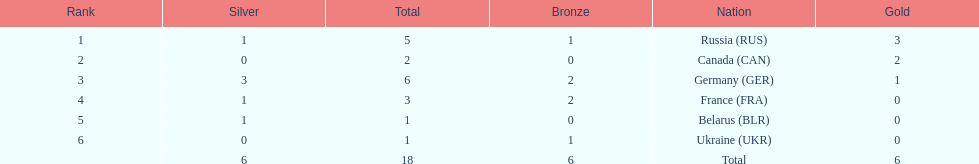Which country won the same amount of silver medals as the french and the russians? Belarus. 